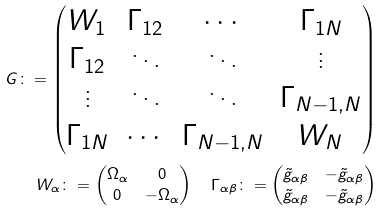Convert formula to latex. <formula><loc_0><loc_0><loc_500><loc_500>G \colon = \begin{pmatrix} W _ { 1 } & \Gamma _ { 1 2 } & \cdots & \Gamma _ { 1 N } \\ \Gamma _ { 1 2 } & \ddots & \ddots & \vdots \\ \vdots & \ddots & \ddots & \Gamma _ { N - 1 , N } \\ \Gamma _ { 1 N } & \cdots & \Gamma _ { N - 1 , N } & W _ { N } \end{pmatrix} \\ W _ { \alpha } \colon = \begin{pmatrix} \Omega _ { \alpha } & 0 \\ 0 & - \Omega _ { \alpha } \end{pmatrix} \quad \Gamma _ { \alpha \beta } \colon = \begin{pmatrix} \tilde { g } _ { \alpha \beta } & - \tilde { g } _ { \alpha \beta } \\ \tilde { g } _ { \alpha \beta } & - \tilde { g } _ { \alpha \beta } \end{pmatrix}</formula> 